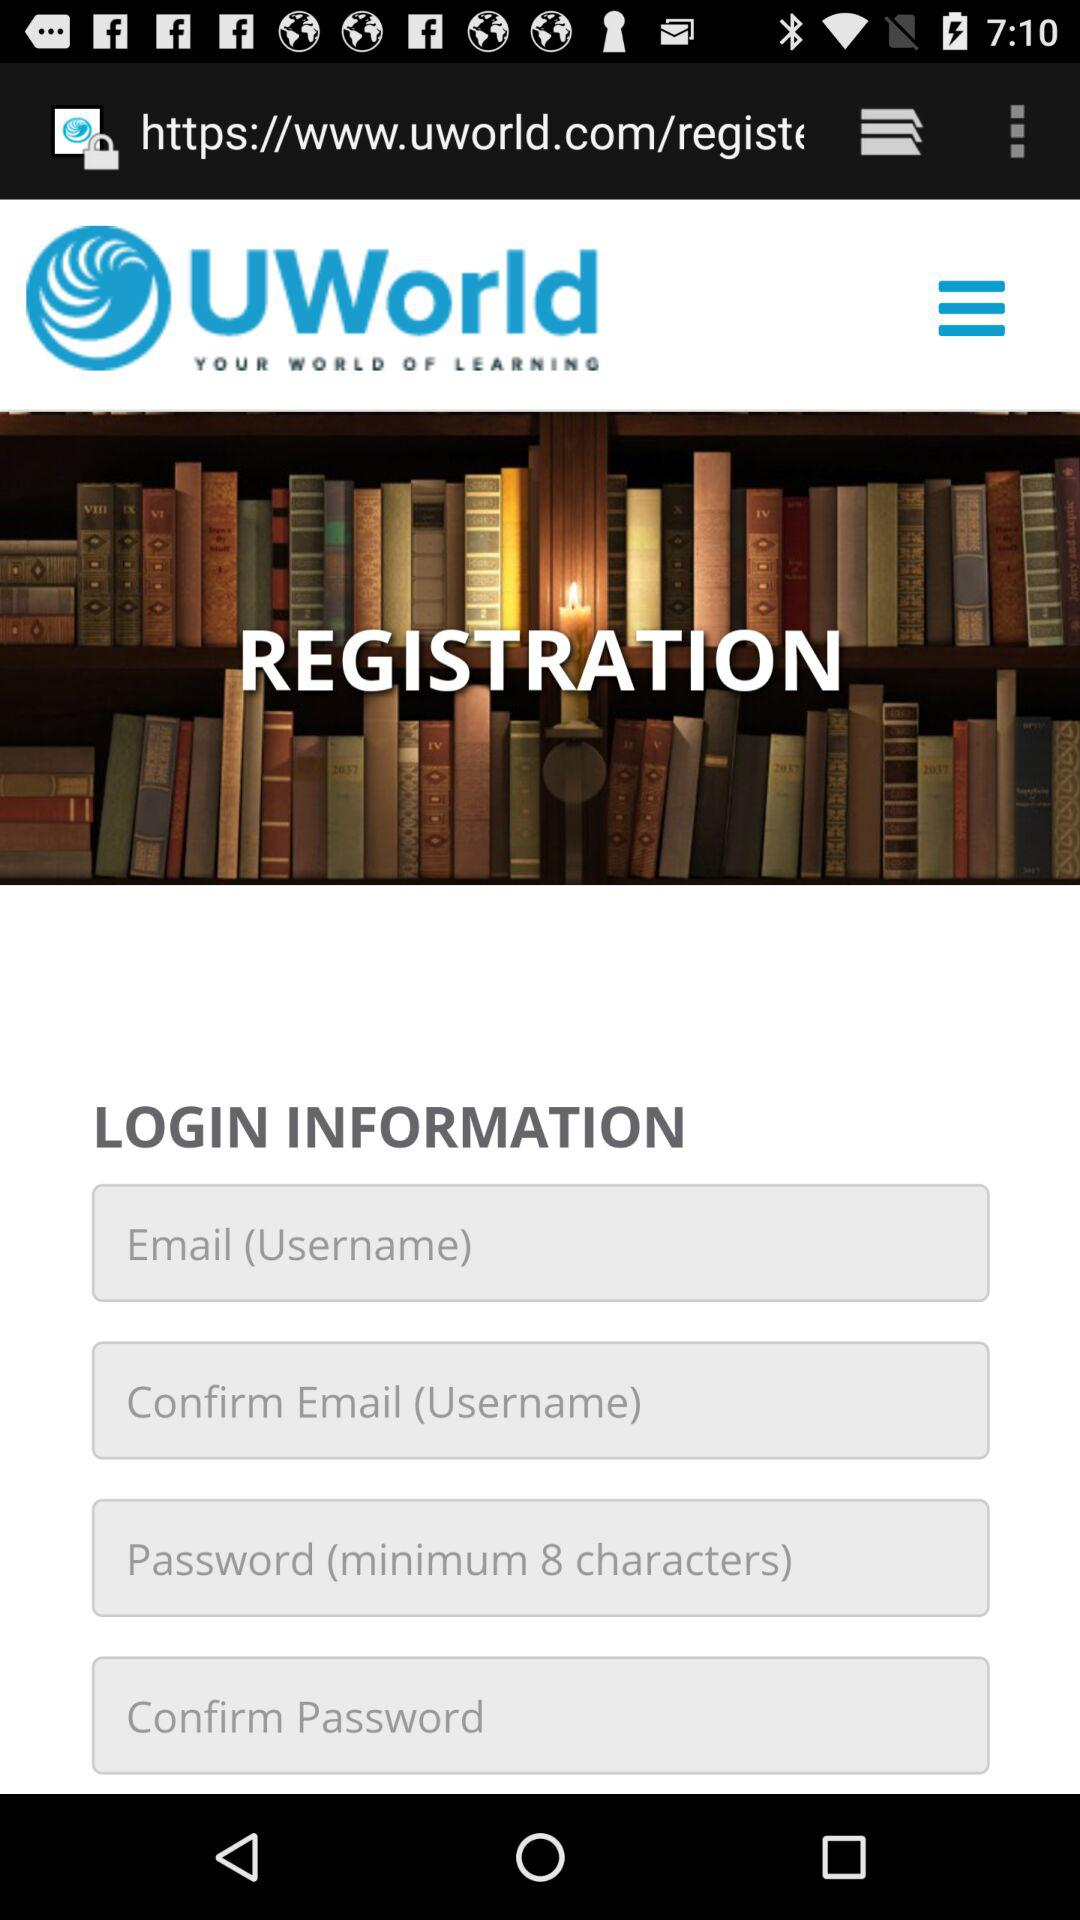What is the application name? The application name is "UWorld". 